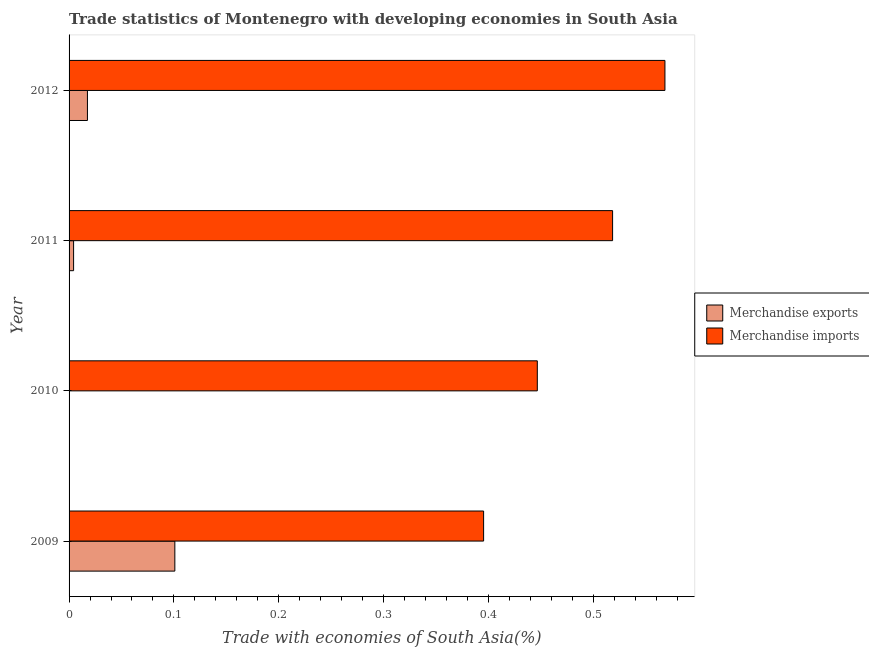What is the label of the 3rd group of bars from the top?
Make the answer very short. 2010. In how many cases, is the number of bars for a given year not equal to the number of legend labels?
Make the answer very short. 0. What is the merchandise exports in 2010?
Your response must be concise. 0. Across all years, what is the maximum merchandise exports?
Your response must be concise. 0.1. Across all years, what is the minimum merchandise imports?
Ensure brevity in your answer.  0.4. In which year was the merchandise imports maximum?
Make the answer very short. 2012. In which year was the merchandise exports minimum?
Your response must be concise. 2010. What is the total merchandise imports in the graph?
Your response must be concise. 1.93. What is the difference between the merchandise exports in 2010 and that in 2012?
Provide a succinct answer. -0.02. What is the difference between the merchandise exports in 2011 and the merchandise imports in 2012?
Your answer should be very brief. -0.56. What is the average merchandise imports per year?
Offer a terse response. 0.48. In the year 2011, what is the difference between the merchandise imports and merchandise exports?
Make the answer very short. 0.51. In how many years, is the merchandise imports greater than 0.2 %?
Your answer should be compact. 4. What is the ratio of the merchandise imports in 2009 to that in 2010?
Keep it short and to the point. 0.89. Is the merchandise imports in 2010 less than that in 2012?
Ensure brevity in your answer.  Yes. Is the difference between the merchandise imports in 2010 and 2012 greater than the difference between the merchandise exports in 2010 and 2012?
Ensure brevity in your answer.  No. What is the difference between the highest and the second highest merchandise imports?
Your answer should be compact. 0.05. What is the difference between the highest and the lowest merchandise imports?
Your answer should be compact. 0.17. In how many years, is the merchandise exports greater than the average merchandise exports taken over all years?
Keep it short and to the point. 1. Is the sum of the merchandise exports in 2010 and 2012 greater than the maximum merchandise imports across all years?
Your answer should be very brief. No. What does the 2nd bar from the top in 2010 represents?
Keep it short and to the point. Merchandise exports. What does the 2nd bar from the bottom in 2012 represents?
Provide a short and direct response. Merchandise imports. How many bars are there?
Offer a terse response. 8. How many years are there in the graph?
Your answer should be very brief. 4. What is the difference between two consecutive major ticks on the X-axis?
Give a very brief answer. 0.1. Are the values on the major ticks of X-axis written in scientific E-notation?
Provide a succinct answer. No. Where does the legend appear in the graph?
Your answer should be compact. Center right. How many legend labels are there?
Your response must be concise. 2. How are the legend labels stacked?
Give a very brief answer. Vertical. What is the title of the graph?
Your answer should be very brief. Trade statistics of Montenegro with developing economies in South Asia. Does "% of gross capital formation" appear as one of the legend labels in the graph?
Ensure brevity in your answer.  No. What is the label or title of the X-axis?
Give a very brief answer. Trade with economies of South Asia(%). What is the Trade with economies of South Asia(%) of Merchandise exports in 2009?
Your response must be concise. 0.1. What is the Trade with economies of South Asia(%) of Merchandise imports in 2009?
Keep it short and to the point. 0.4. What is the Trade with economies of South Asia(%) of Merchandise exports in 2010?
Your answer should be compact. 0. What is the Trade with economies of South Asia(%) in Merchandise imports in 2010?
Offer a very short reply. 0.45. What is the Trade with economies of South Asia(%) of Merchandise exports in 2011?
Your answer should be very brief. 0. What is the Trade with economies of South Asia(%) in Merchandise imports in 2011?
Ensure brevity in your answer.  0.52. What is the Trade with economies of South Asia(%) of Merchandise exports in 2012?
Your answer should be compact. 0.02. What is the Trade with economies of South Asia(%) of Merchandise imports in 2012?
Provide a short and direct response. 0.57. Across all years, what is the maximum Trade with economies of South Asia(%) of Merchandise exports?
Provide a succinct answer. 0.1. Across all years, what is the maximum Trade with economies of South Asia(%) in Merchandise imports?
Keep it short and to the point. 0.57. Across all years, what is the minimum Trade with economies of South Asia(%) in Merchandise exports?
Give a very brief answer. 0. Across all years, what is the minimum Trade with economies of South Asia(%) in Merchandise imports?
Ensure brevity in your answer.  0.4. What is the total Trade with economies of South Asia(%) of Merchandise exports in the graph?
Your response must be concise. 0.12. What is the total Trade with economies of South Asia(%) in Merchandise imports in the graph?
Your response must be concise. 1.93. What is the difference between the Trade with economies of South Asia(%) of Merchandise exports in 2009 and that in 2010?
Ensure brevity in your answer.  0.1. What is the difference between the Trade with economies of South Asia(%) in Merchandise imports in 2009 and that in 2010?
Keep it short and to the point. -0.05. What is the difference between the Trade with economies of South Asia(%) in Merchandise exports in 2009 and that in 2011?
Offer a very short reply. 0.1. What is the difference between the Trade with economies of South Asia(%) in Merchandise imports in 2009 and that in 2011?
Make the answer very short. -0.12. What is the difference between the Trade with economies of South Asia(%) of Merchandise exports in 2009 and that in 2012?
Offer a very short reply. 0.08. What is the difference between the Trade with economies of South Asia(%) of Merchandise imports in 2009 and that in 2012?
Your answer should be very brief. -0.17. What is the difference between the Trade with economies of South Asia(%) of Merchandise exports in 2010 and that in 2011?
Provide a succinct answer. -0. What is the difference between the Trade with economies of South Asia(%) of Merchandise imports in 2010 and that in 2011?
Your response must be concise. -0.07. What is the difference between the Trade with economies of South Asia(%) of Merchandise exports in 2010 and that in 2012?
Ensure brevity in your answer.  -0.02. What is the difference between the Trade with economies of South Asia(%) in Merchandise imports in 2010 and that in 2012?
Ensure brevity in your answer.  -0.12. What is the difference between the Trade with economies of South Asia(%) in Merchandise exports in 2011 and that in 2012?
Offer a very short reply. -0.01. What is the difference between the Trade with economies of South Asia(%) of Merchandise imports in 2011 and that in 2012?
Your answer should be compact. -0.05. What is the difference between the Trade with economies of South Asia(%) in Merchandise exports in 2009 and the Trade with economies of South Asia(%) in Merchandise imports in 2010?
Your answer should be very brief. -0.35. What is the difference between the Trade with economies of South Asia(%) in Merchandise exports in 2009 and the Trade with economies of South Asia(%) in Merchandise imports in 2011?
Make the answer very short. -0.42. What is the difference between the Trade with economies of South Asia(%) of Merchandise exports in 2009 and the Trade with economies of South Asia(%) of Merchandise imports in 2012?
Your answer should be very brief. -0.47. What is the difference between the Trade with economies of South Asia(%) of Merchandise exports in 2010 and the Trade with economies of South Asia(%) of Merchandise imports in 2011?
Provide a succinct answer. -0.52. What is the difference between the Trade with economies of South Asia(%) of Merchandise exports in 2010 and the Trade with economies of South Asia(%) of Merchandise imports in 2012?
Offer a very short reply. -0.57. What is the difference between the Trade with economies of South Asia(%) in Merchandise exports in 2011 and the Trade with economies of South Asia(%) in Merchandise imports in 2012?
Offer a terse response. -0.56. What is the average Trade with economies of South Asia(%) in Merchandise exports per year?
Your answer should be compact. 0.03. What is the average Trade with economies of South Asia(%) in Merchandise imports per year?
Give a very brief answer. 0.48. In the year 2009, what is the difference between the Trade with economies of South Asia(%) in Merchandise exports and Trade with economies of South Asia(%) in Merchandise imports?
Provide a short and direct response. -0.29. In the year 2010, what is the difference between the Trade with economies of South Asia(%) in Merchandise exports and Trade with economies of South Asia(%) in Merchandise imports?
Your answer should be very brief. -0.45. In the year 2011, what is the difference between the Trade with economies of South Asia(%) in Merchandise exports and Trade with economies of South Asia(%) in Merchandise imports?
Ensure brevity in your answer.  -0.51. In the year 2012, what is the difference between the Trade with economies of South Asia(%) of Merchandise exports and Trade with economies of South Asia(%) of Merchandise imports?
Give a very brief answer. -0.55. What is the ratio of the Trade with economies of South Asia(%) in Merchandise exports in 2009 to that in 2010?
Your response must be concise. 665.45. What is the ratio of the Trade with economies of South Asia(%) in Merchandise imports in 2009 to that in 2010?
Offer a very short reply. 0.89. What is the ratio of the Trade with economies of South Asia(%) in Merchandise exports in 2009 to that in 2011?
Offer a terse response. 23.42. What is the ratio of the Trade with economies of South Asia(%) in Merchandise imports in 2009 to that in 2011?
Your answer should be compact. 0.76. What is the ratio of the Trade with economies of South Asia(%) in Merchandise exports in 2009 to that in 2012?
Provide a succinct answer. 5.76. What is the ratio of the Trade with economies of South Asia(%) of Merchandise imports in 2009 to that in 2012?
Offer a terse response. 0.7. What is the ratio of the Trade with economies of South Asia(%) of Merchandise exports in 2010 to that in 2011?
Ensure brevity in your answer.  0.04. What is the ratio of the Trade with economies of South Asia(%) of Merchandise imports in 2010 to that in 2011?
Give a very brief answer. 0.86. What is the ratio of the Trade with economies of South Asia(%) of Merchandise exports in 2010 to that in 2012?
Offer a terse response. 0.01. What is the ratio of the Trade with economies of South Asia(%) in Merchandise imports in 2010 to that in 2012?
Your response must be concise. 0.79. What is the ratio of the Trade with economies of South Asia(%) of Merchandise exports in 2011 to that in 2012?
Make the answer very short. 0.25. What is the ratio of the Trade with economies of South Asia(%) in Merchandise imports in 2011 to that in 2012?
Offer a terse response. 0.91. What is the difference between the highest and the second highest Trade with economies of South Asia(%) in Merchandise exports?
Ensure brevity in your answer.  0.08. What is the difference between the highest and the second highest Trade with economies of South Asia(%) of Merchandise imports?
Your answer should be very brief. 0.05. What is the difference between the highest and the lowest Trade with economies of South Asia(%) of Merchandise exports?
Provide a short and direct response. 0.1. What is the difference between the highest and the lowest Trade with economies of South Asia(%) in Merchandise imports?
Offer a very short reply. 0.17. 